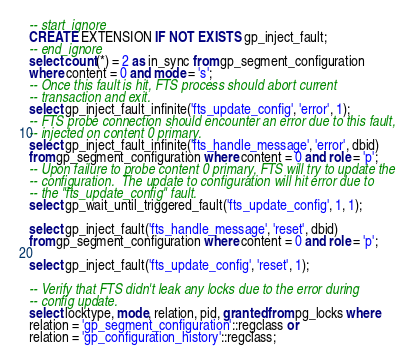Convert code to text. <code><loc_0><loc_0><loc_500><loc_500><_SQL_>-- start_ignore
CREATE EXTENSION IF NOT EXISTS gp_inject_fault;
-- end_ignore
select count(*) = 2 as in_sync from gp_segment_configuration
where content = 0 and mode = 's';
-- Once this fault is hit, FTS process should abort current
-- transaction and exit.
select gp_inject_fault_infinite('fts_update_config', 'error', 1);
-- FTS probe connection should encounter an error due to this fault,
-- injected on content 0 primary.
select gp_inject_fault_infinite('fts_handle_message', 'error', dbid)
from gp_segment_configuration where content = 0 and role = 'p';
-- Upon failure to probe content 0 primary, FTS will try to update the
-- configuration.  The update to configuration will hit error due to
-- the "fts_update_config" fault.
select gp_wait_until_triggered_fault('fts_update_config', 1, 1);

select gp_inject_fault('fts_handle_message', 'reset', dbid)
from gp_segment_configuration where content = 0 and role = 'p';

select gp_inject_fault('fts_update_config', 'reset', 1);

-- Verify that FTS didn't leak any locks due to the error during
-- config update.
select locktype, mode, relation, pid, granted from pg_locks where
relation = 'gp_segment_configuration'::regclass or
relation = 'gp_configuration_history'::regclass;</code> 